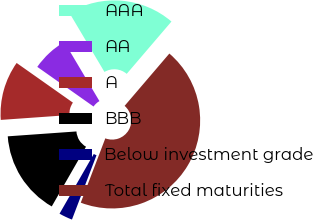Convert chart. <chart><loc_0><loc_0><loc_500><loc_500><pie_chart><fcel>AAA<fcel>AA<fcel>A<fcel>BBB<fcel>Below investment grade<fcel>Total fixed maturities<nl><fcel>19.79%<fcel>6.7%<fcel>10.9%<fcel>15.58%<fcel>2.49%<fcel>44.54%<nl></chart> 